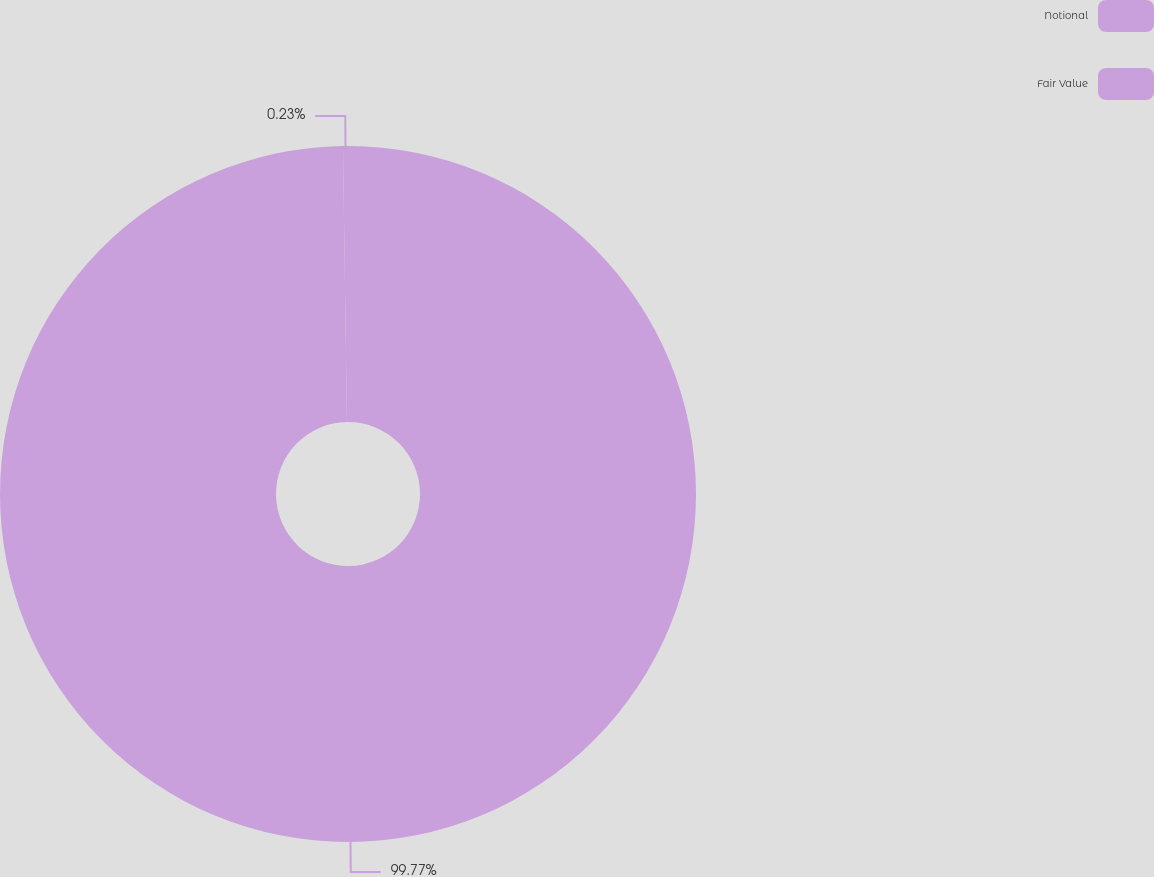Convert chart. <chart><loc_0><loc_0><loc_500><loc_500><pie_chart><fcel>Notional<fcel>Fair Value<nl><fcel>99.77%<fcel>0.23%<nl></chart> 